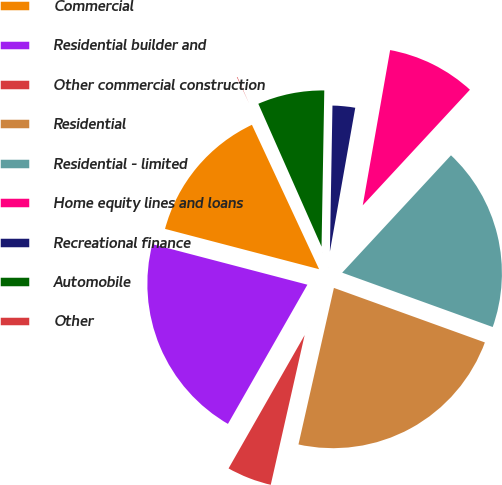Convert chart. <chart><loc_0><loc_0><loc_500><loc_500><pie_chart><fcel>Commercial<fcel>Residential builder and<fcel>Other commercial construction<fcel>Residential<fcel>Residential - limited<fcel>Home equity lines and loans<fcel>Recreational finance<fcel>Automobile<fcel>Other<nl><fcel>14.0%<fcel>20.82%<fcel>4.71%<fcel>23.03%<fcel>18.62%<fcel>9.12%<fcel>2.5%<fcel>6.91%<fcel>0.3%<nl></chart> 